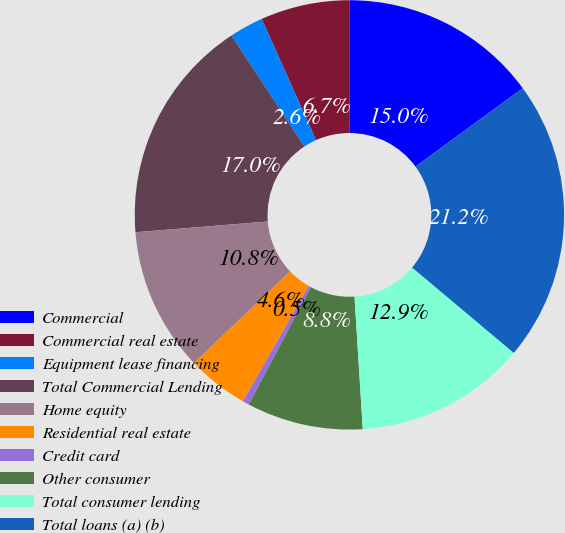<chart> <loc_0><loc_0><loc_500><loc_500><pie_chart><fcel>Commercial<fcel>Commercial real estate<fcel>Equipment lease financing<fcel>Total Commercial Lending<fcel>Home equity<fcel>Residential real estate<fcel>Credit card<fcel>Other consumer<fcel>Total consumer lending<fcel>Total loans (a) (b)<nl><fcel>14.96%<fcel>6.69%<fcel>2.56%<fcel>17.03%<fcel>10.83%<fcel>4.62%<fcel>0.49%<fcel>8.76%<fcel>12.89%<fcel>21.16%<nl></chart> 